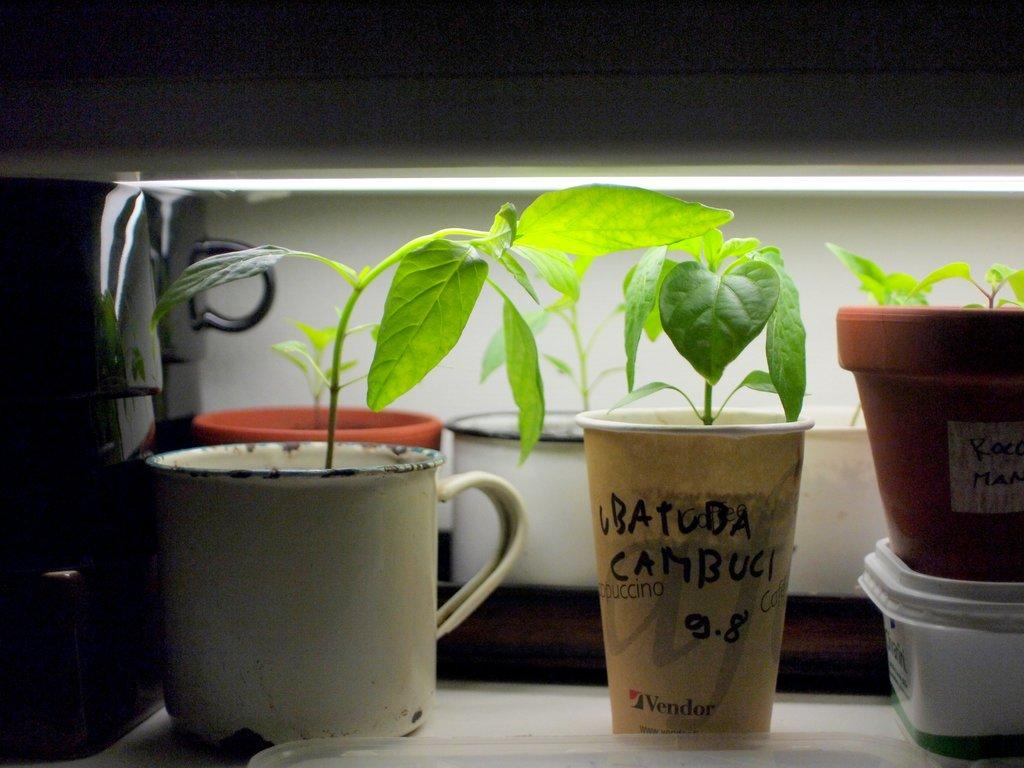What is one object that can be seen in the picture? There is a cup in the picture. What living organism is present in the picture? There is a plant in the picture. What container is holding the plant? There is a flower pot in the picture. What type of duck can be seen swimming in the flower pot? There is no duck present in the image; it features a cup, plant, and flower pot. What kind of paper is being used to wrap the plant in the picture? There is no paper visible in the image; it only shows a cup, plant, and flower pot. 